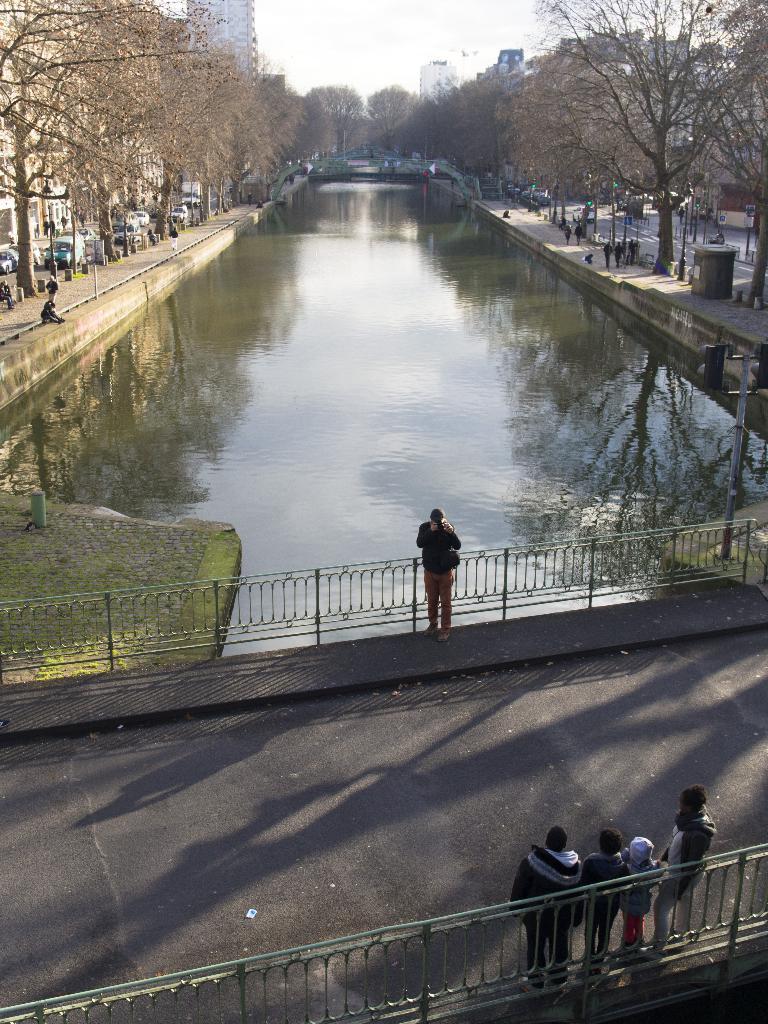Please provide a concise description of this image. In this image there are a few people standing on the bridge, in front of them there is a water body. On the left and right side of the image there are buildings and trees. In front of them there are a few vehicles moving on the road and few people are walking on the pavement. In the background there is the sky. 